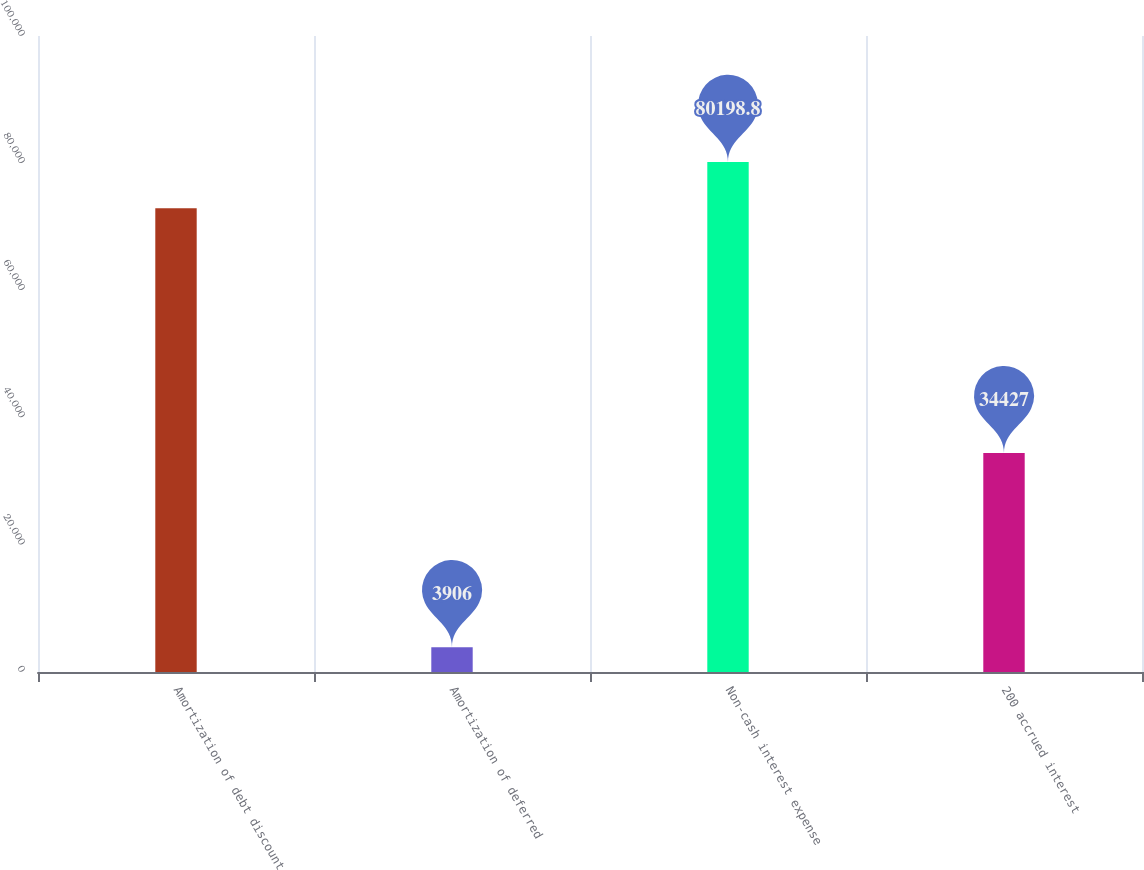<chart> <loc_0><loc_0><loc_500><loc_500><bar_chart><fcel>Amortization of debt discount<fcel>Amortization of deferred<fcel>Non-cash interest expense<fcel>200 accrued interest<nl><fcel>72908<fcel>3906<fcel>80198.8<fcel>34427<nl></chart> 